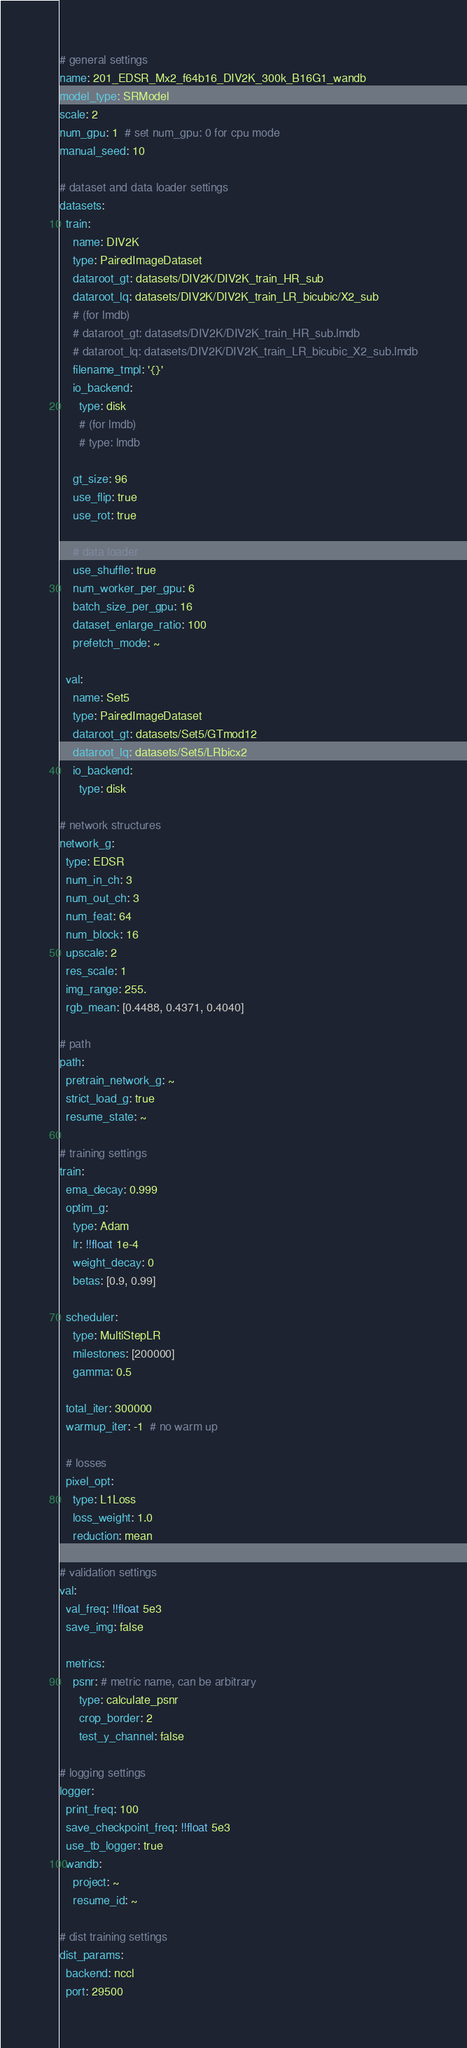<code> <loc_0><loc_0><loc_500><loc_500><_YAML_># general settings
name: 201_EDSR_Mx2_f64b16_DIV2K_300k_B16G1_wandb
model_type: SRModel
scale: 2
num_gpu: 1  # set num_gpu: 0 for cpu mode
manual_seed: 10

# dataset and data loader settings
datasets:
  train:
    name: DIV2K
    type: PairedImageDataset
    dataroot_gt: datasets/DIV2K/DIV2K_train_HR_sub
    dataroot_lq: datasets/DIV2K/DIV2K_train_LR_bicubic/X2_sub
    # (for lmdb)
    # dataroot_gt: datasets/DIV2K/DIV2K_train_HR_sub.lmdb
    # dataroot_lq: datasets/DIV2K/DIV2K_train_LR_bicubic_X2_sub.lmdb
    filename_tmpl: '{}'
    io_backend:
      type: disk
      # (for lmdb)
      # type: lmdb

    gt_size: 96
    use_flip: true
    use_rot: true

    # data loader
    use_shuffle: true
    num_worker_per_gpu: 6
    batch_size_per_gpu: 16
    dataset_enlarge_ratio: 100
    prefetch_mode: ~

  val:
    name: Set5
    type: PairedImageDataset
    dataroot_gt: datasets/Set5/GTmod12
    dataroot_lq: datasets/Set5/LRbicx2
    io_backend:
      type: disk

# network structures
network_g:
  type: EDSR
  num_in_ch: 3
  num_out_ch: 3
  num_feat: 64
  num_block: 16
  upscale: 2
  res_scale: 1
  img_range: 255.
  rgb_mean: [0.4488, 0.4371, 0.4040]

# path
path:
  pretrain_network_g: ~
  strict_load_g: true
  resume_state: ~

# training settings
train:
  ema_decay: 0.999
  optim_g:
    type: Adam
    lr: !!float 1e-4
    weight_decay: 0
    betas: [0.9, 0.99]

  scheduler:
    type: MultiStepLR
    milestones: [200000]
    gamma: 0.5

  total_iter: 300000
  warmup_iter: -1  # no warm up

  # losses
  pixel_opt:
    type: L1Loss
    loss_weight: 1.0
    reduction: mean

# validation settings
val:
  val_freq: !!float 5e3
  save_img: false

  metrics:
    psnr: # metric name, can be arbitrary
      type: calculate_psnr
      crop_border: 2
      test_y_channel: false

# logging settings
logger:
  print_freq: 100
  save_checkpoint_freq: !!float 5e3
  use_tb_logger: true
  wandb:
    project: ~
    resume_id: ~

# dist training settings
dist_params:
  backend: nccl
  port: 29500
</code> 